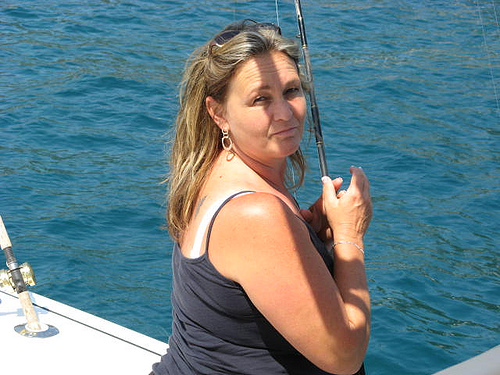<image>
Is the water on the person? No. The water is not positioned on the person. They may be near each other, but the water is not supported by or resting on top of the person. Is the boat under the water? No. The boat is not positioned under the water. The vertical relationship between these objects is different. Where is the women in relation to the water? Is it in the water? No. The women is not contained within the water. These objects have a different spatial relationship. 